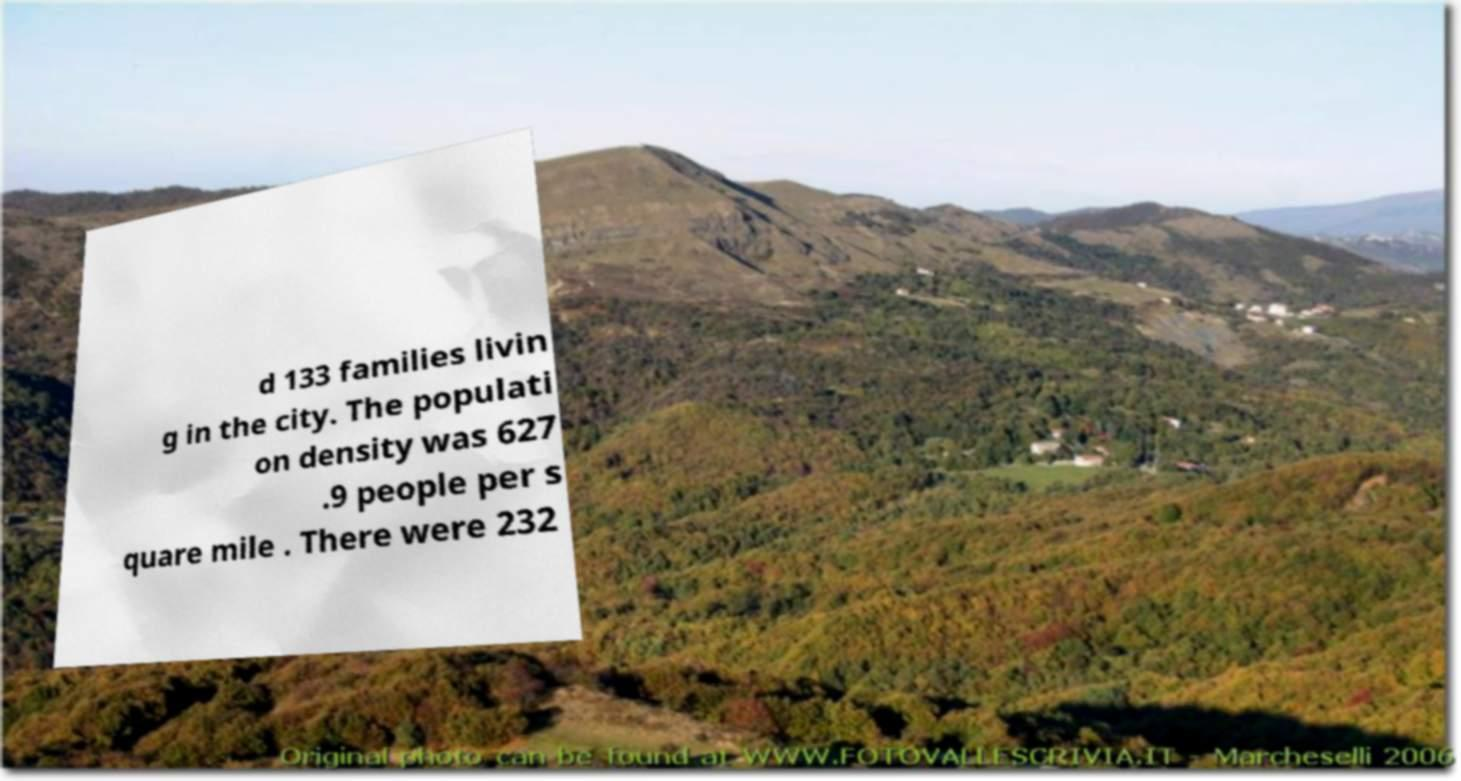There's text embedded in this image that I need extracted. Can you transcribe it verbatim? d 133 families livin g in the city. The populati on density was 627 .9 people per s quare mile . There were 232 